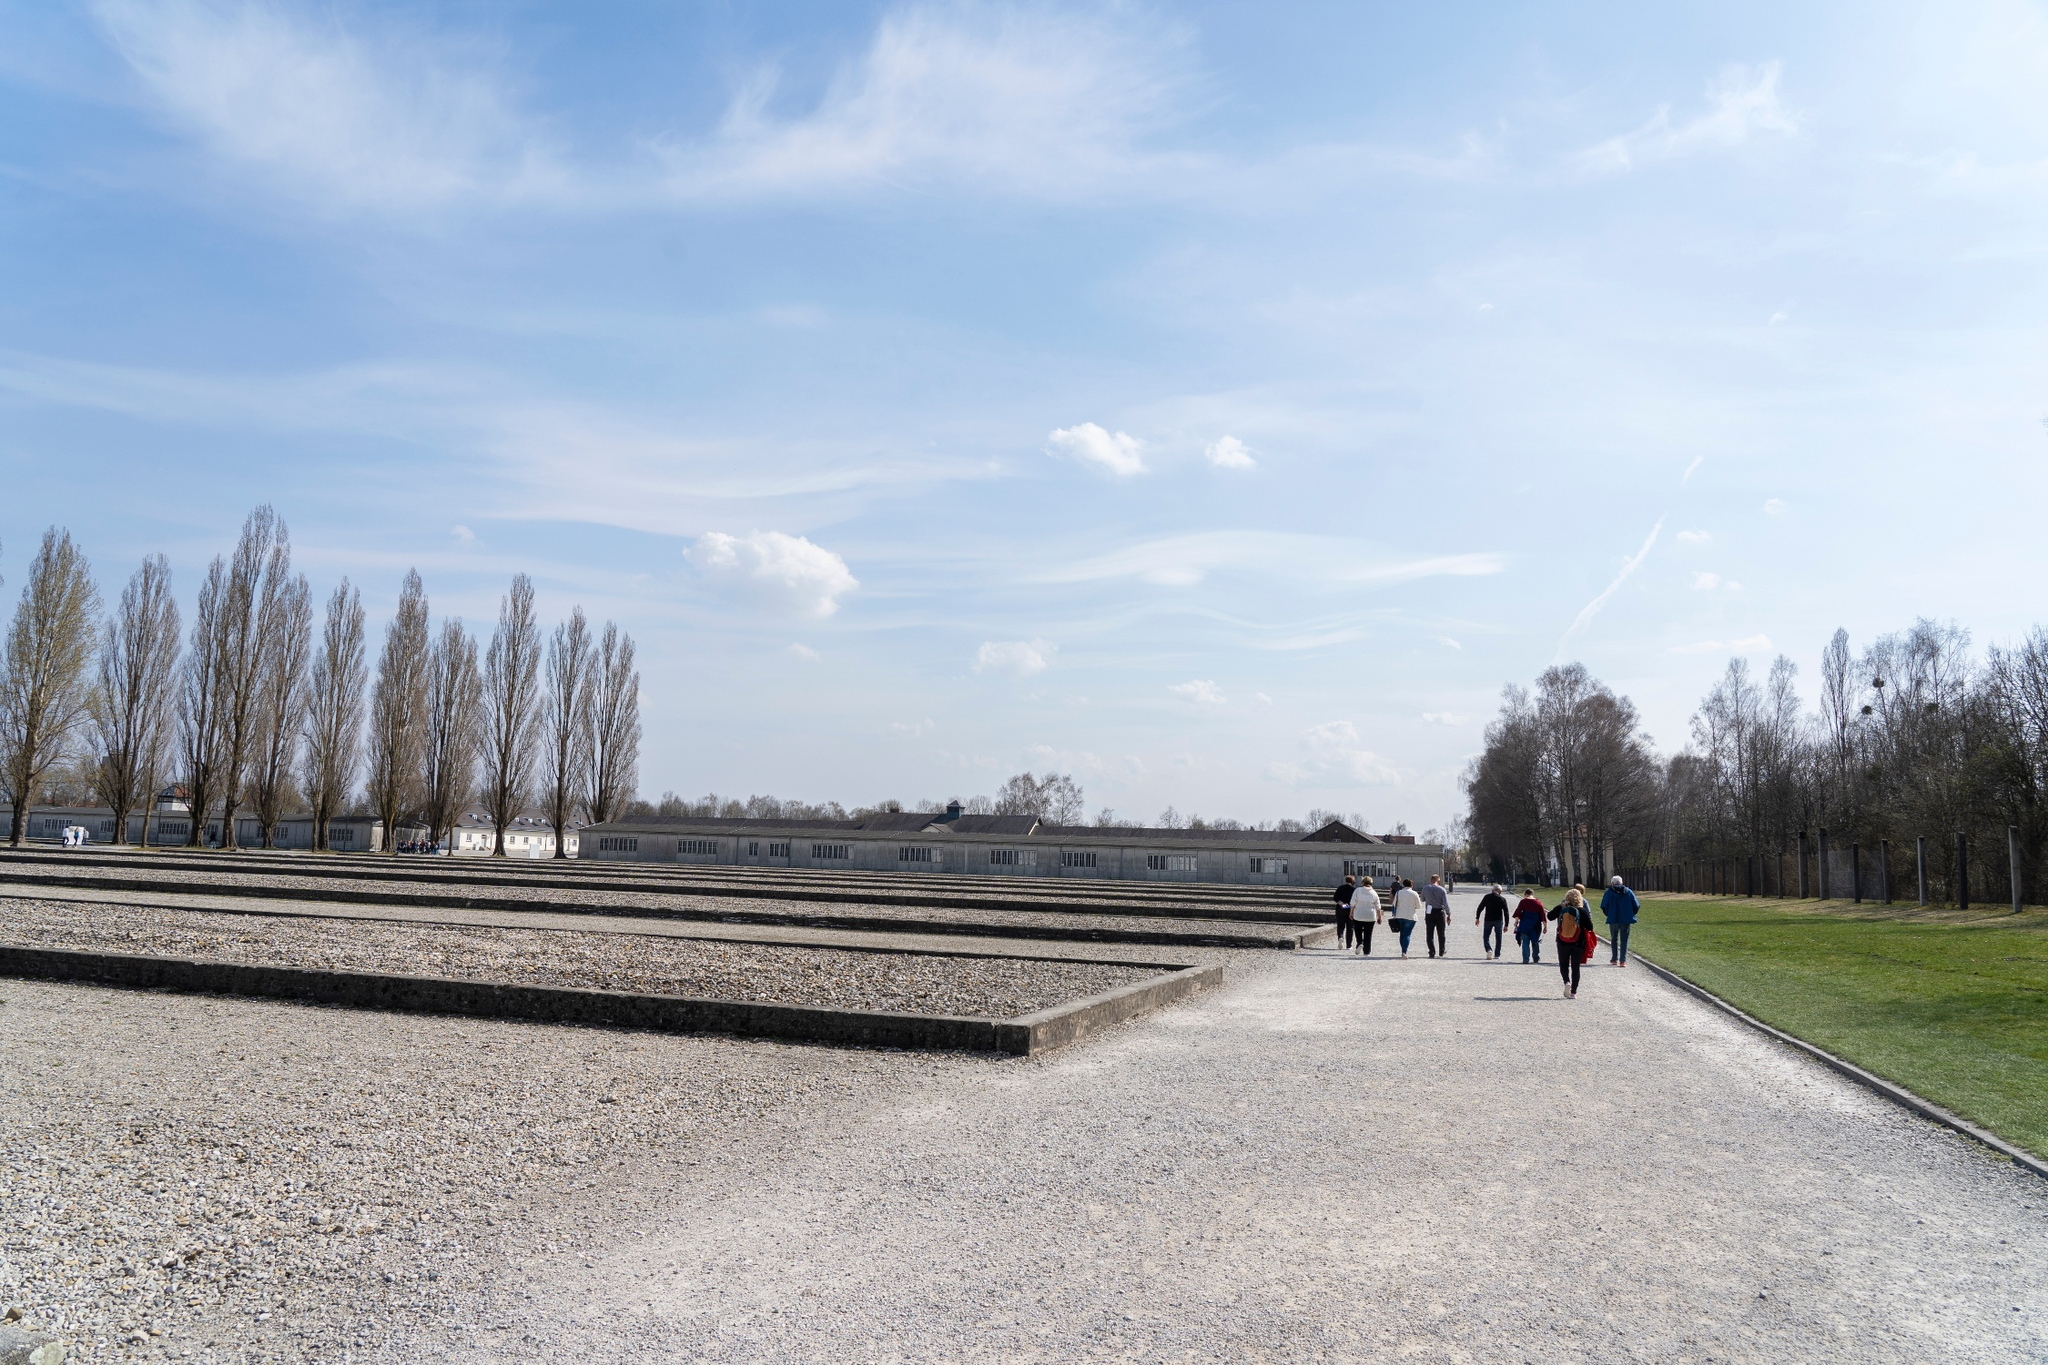Realistic Scenario: Why might someone choose to visit this memorial site? Someone might choose to visit the Dachau Concentration Camp Memorial Site to honor the memory of those who suffered and perished during the Holocaust. They may seek to gain a deeper understanding of the historical events and their impact on humanity. Visiting such a site can also serve as a poignant reminder of the importance of tolerance and the need to learn from the past to ensure such atrocities never happen again. Additionally, educators, students, historians, and those with a personal connection to the events may visit to pay their respects, to learn, and to reflect on the lessons of history. 